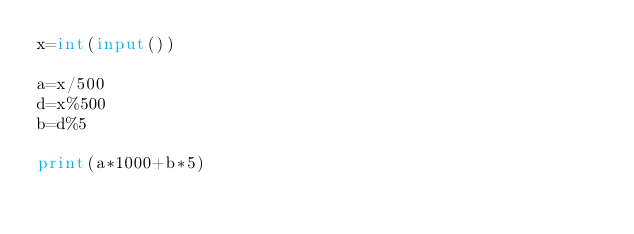<code> <loc_0><loc_0><loc_500><loc_500><_Python_>x=int(input())

a=x/500
d=x%500
b=d%5

print(a*1000+b*5)</code> 